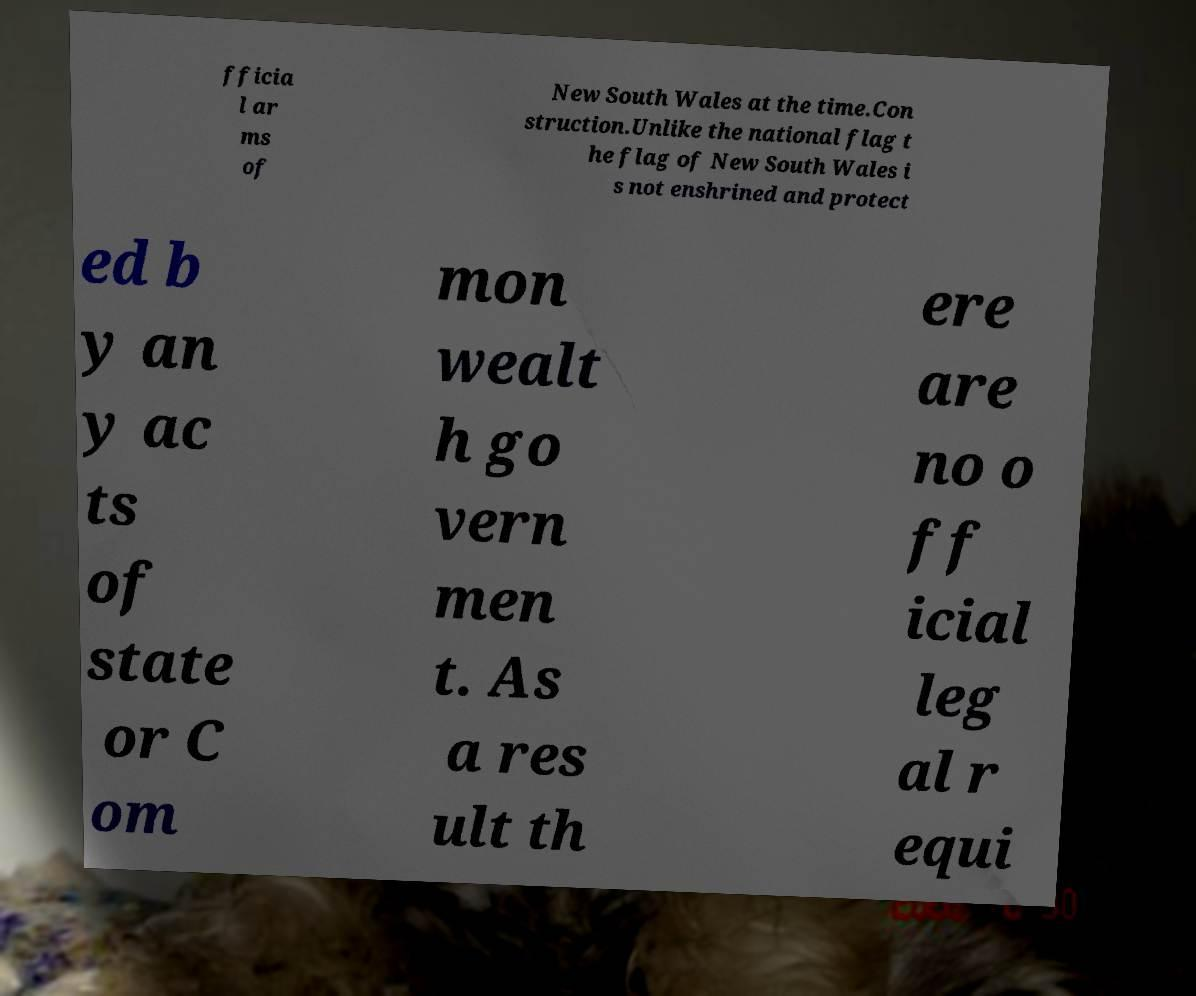I need the written content from this picture converted into text. Can you do that? fficia l ar ms of New South Wales at the time.Con struction.Unlike the national flag t he flag of New South Wales i s not enshrined and protect ed b y an y ac ts of state or C om mon wealt h go vern men t. As a res ult th ere are no o ff icial leg al r equi 